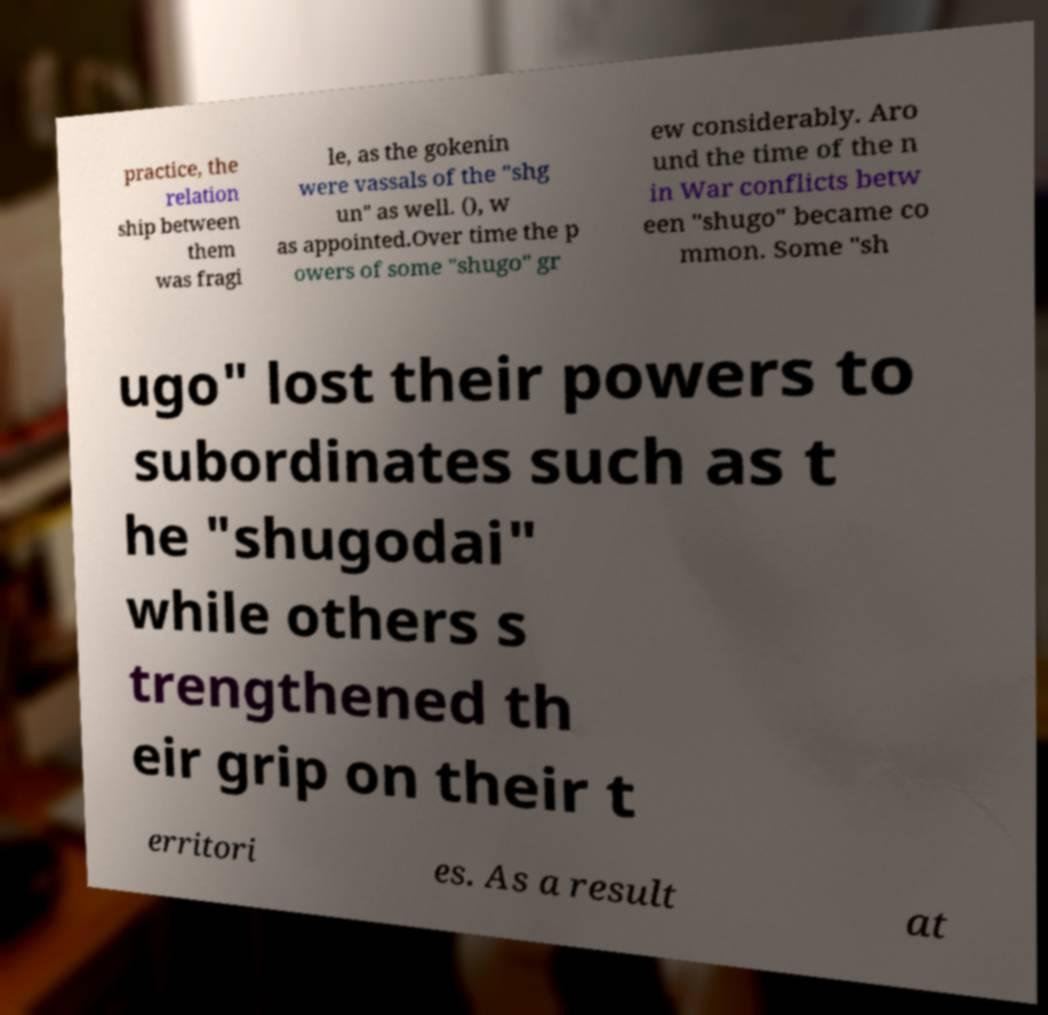Could you extract and type out the text from this image? practice, the relation ship between them was fragi le, as the gokenin were vassals of the "shg un" as well. (), w as appointed.Over time the p owers of some "shugo" gr ew considerably. Aro und the time of the n in War conflicts betw een "shugo" became co mmon. Some "sh ugo" lost their powers to subordinates such as t he "shugodai" while others s trengthened th eir grip on their t erritori es. As a result at 